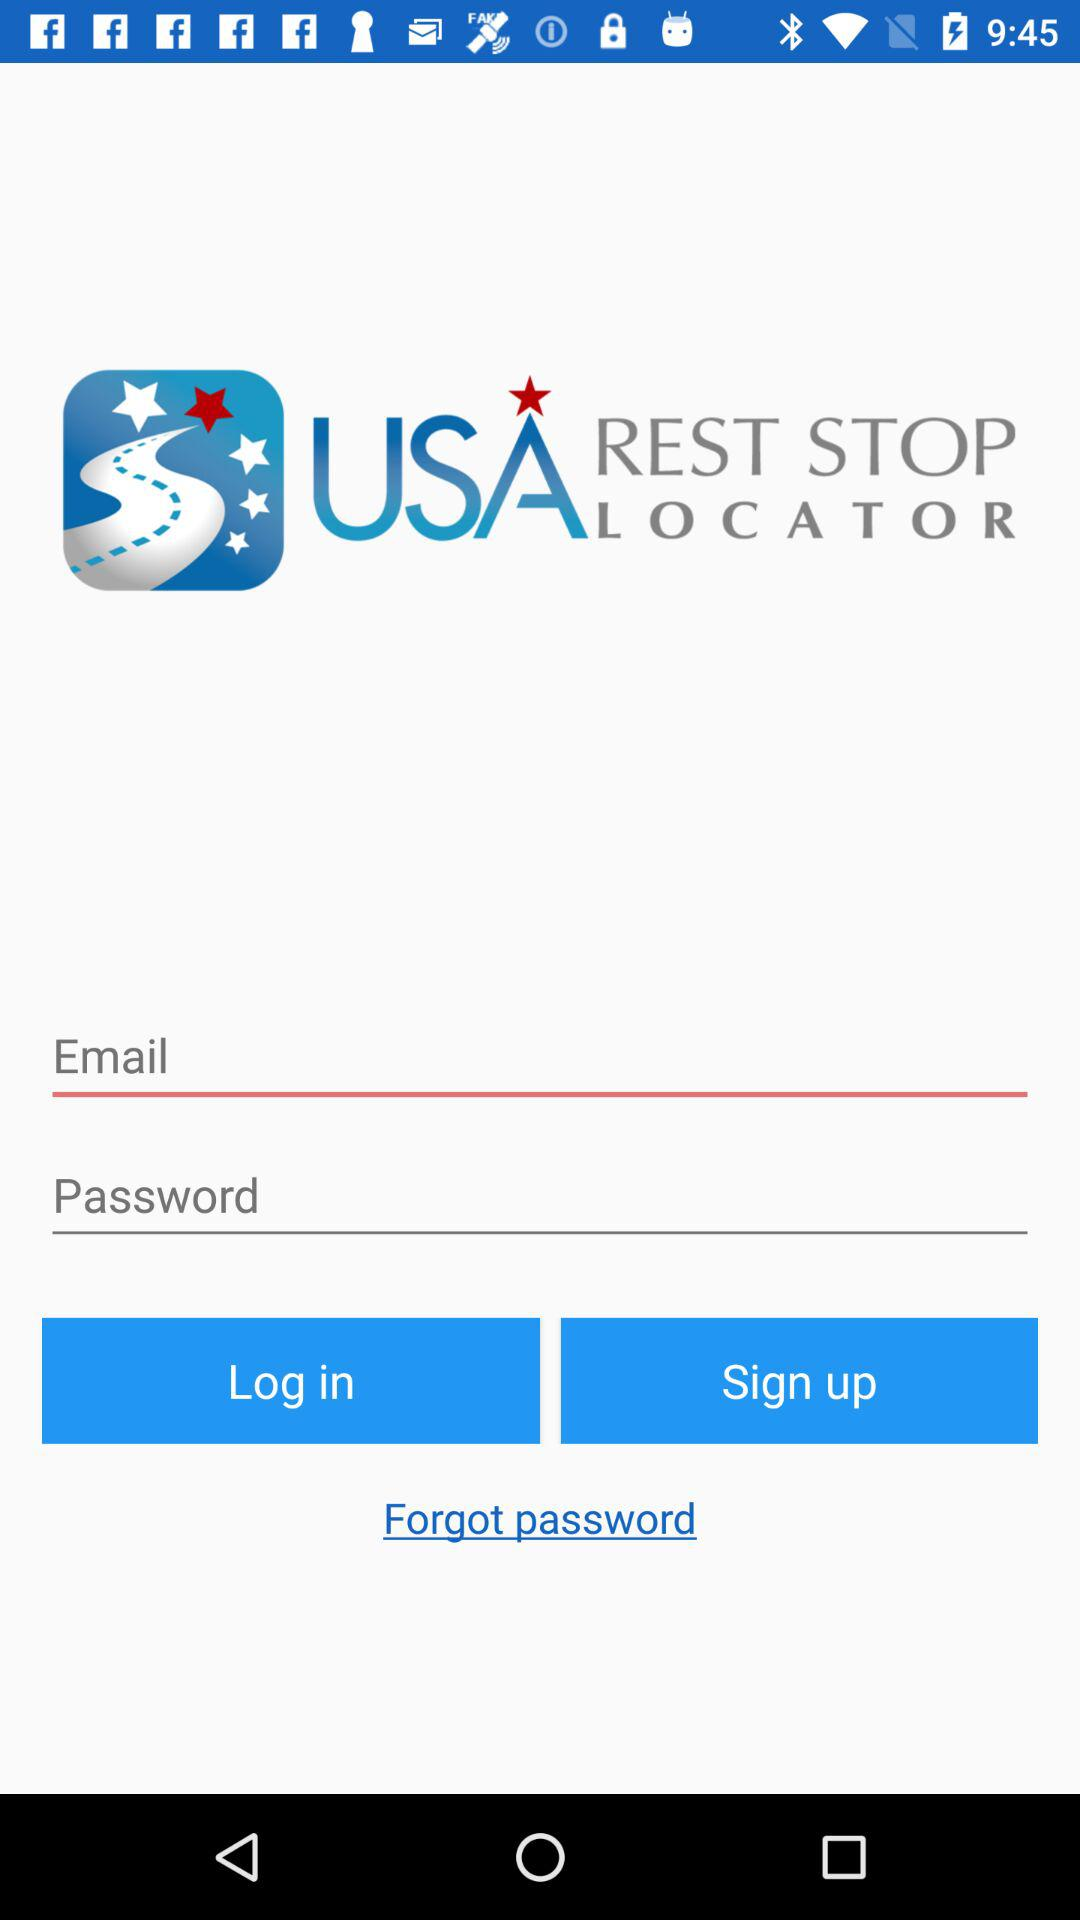How many characters are required to create a password?
When the provided information is insufficient, respond with <no answer>. <no answer> 